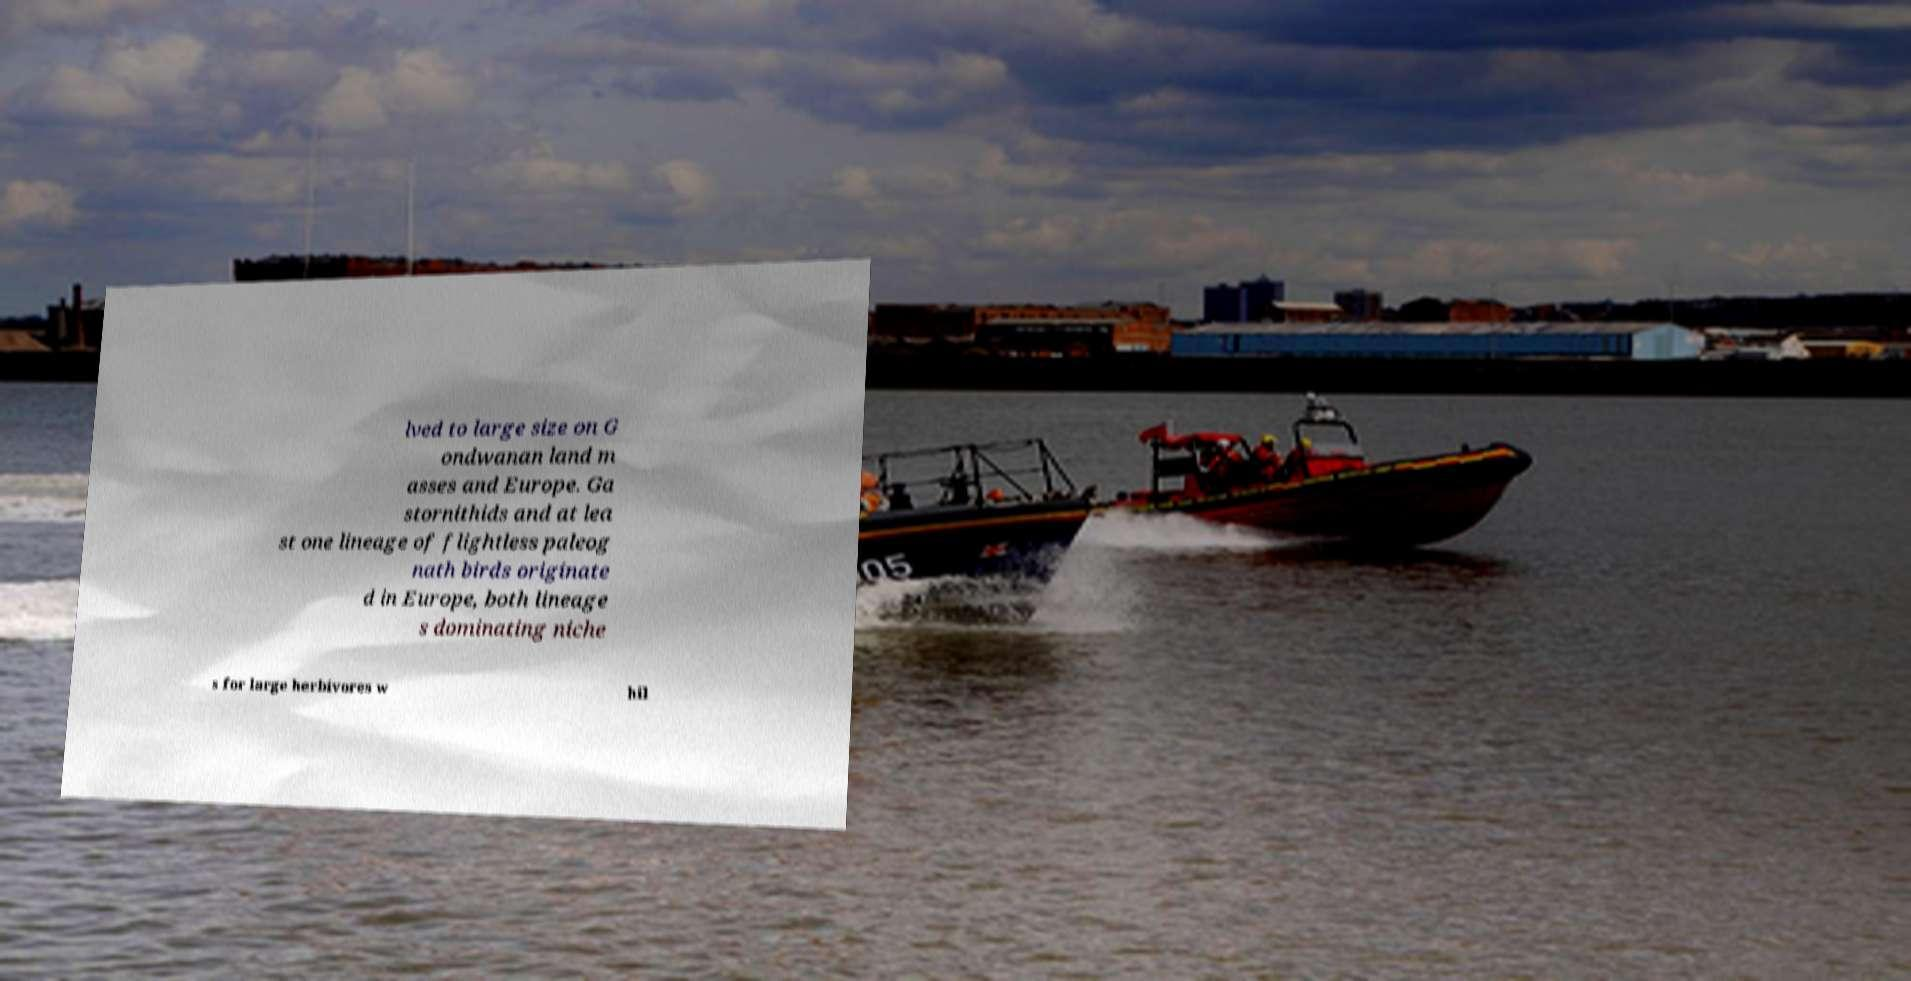What messages or text are displayed in this image? I need them in a readable, typed format. lved to large size on G ondwanan land m asses and Europe. Ga stornithids and at lea st one lineage of flightless paleog nath birds originate d in Europe, both lineage s dominating niche s for large herbivores w hil 